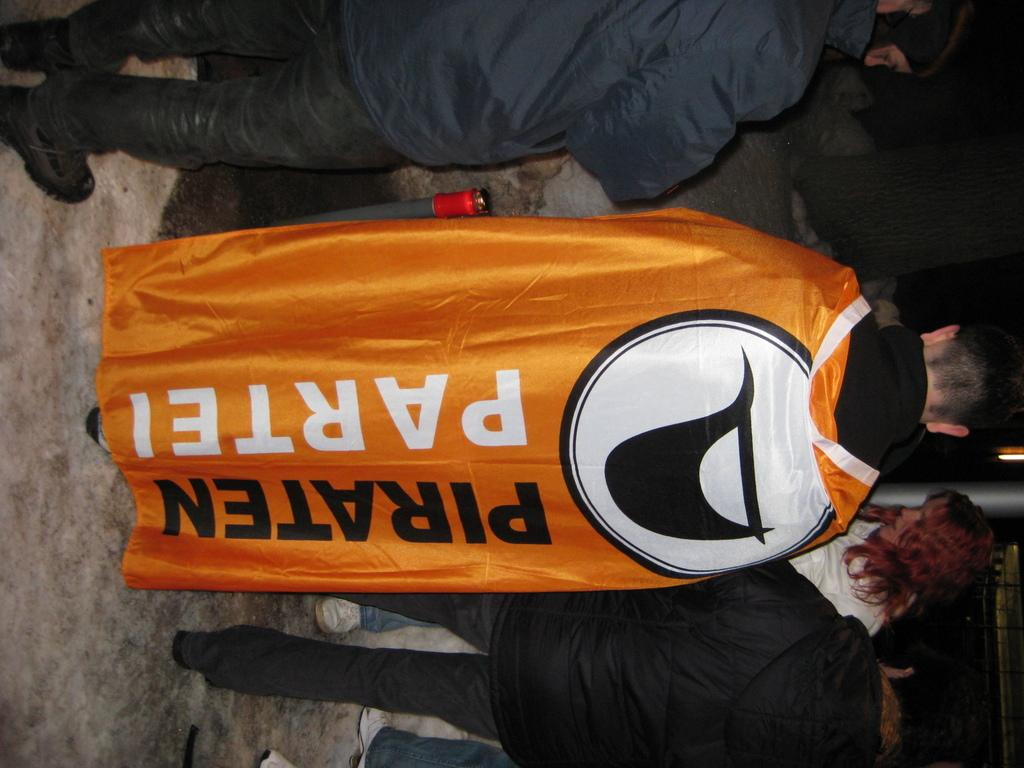<image>
Provide a brief description of the given image. The back of the man's cape says Piraten Partei. 